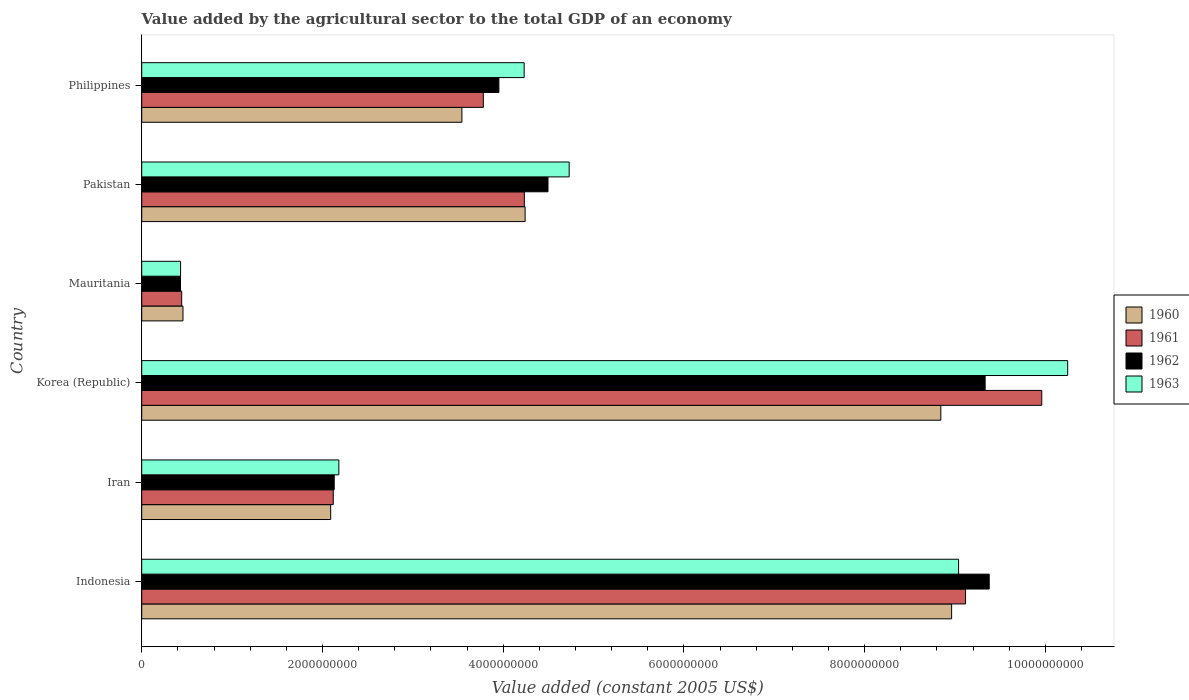How many groups of bars are there?
Give a very brief answer. 6. Are the number of bars per tick equal to the number of legend labels?
Your answer should be very brief. Yes. Are the number of bars on each tick of the Y-axis equal?
Your response must be concise. Yes. How many bars are there on the 2nd tick from the top?
Your answer should be very brief. 4. What is the value added by the agricultural sector in 1961 in Korea (Republic)?
Give a very brief answer. 9.96e+09. Across all countries, what is the maximum value added by the agricultural sector in 1960?
Your response must be concise. 8.96e+09. Across all countries, what is the minimum value added by the agricultural sector in 1961?
Provide a short and direct response. 4.42e+08. In which country was the value added by the agricultural sector in 1962 minimum?
Ensure brevity in your answer.  Mauritania. What is the total value added by the agricultural sector in 1961 in the graph?
Offer a very short reply. 2.97e+1. What is the difference between the value added by the agricultural sector in 1961 in Pakistan and that in Philippines?
Your answer should be very brief. 4.54e+08. What is the difference between the value added by the agricultural sector in 1963 in Indonesia and the value added by the agricultural sector in 1961 in Philippines?
Offer a terse response. 5.26e+09. What is the average value added by the agricultural sector in 1960 per country?
Provide a short and direct response. 4.69e+09. What is the difference between the value added by the agricultural sector in 1962 and value added by the agricultural sector in 1963 in Mauritania?
Keep it short and to the point. -7.06e+05. What is the ratio of the value added by the agricultural sector in 1960 in Indonesia to that in Korea (Republic)?
Offer a very short reply. 1.01. What is the difference between the highest and the second highest value added by the agricultural sector in 1963?
Your answer should be very brief. 1.21e+09. What is the difference between the highest and the lowest value added by the agricultural sector in 1960?
Ensure brevity in your answer.  8.51e+09. In how many countries, is the value added by the agricultural sector in 1963 greater than the average value added by the agricultural sector in 1963 taken over all countries?
Give a very brief answer. 2. What does the 4th bar from the top in Mauritania represents?
Your answer should be very brief. 1960. What does the 1st bar from the bottom in Mauritania represents?
Provide a succinct answer. 1960. Are all the bars in the graph horizontal?
Provide a short and direct response. Yes. How many countries are there in the graph?
Your response must be concise. 6. Does the graph contain any zero values?
Keep it short and to the point. No. Does the graph contain grids?
Give a very brief answer. No. How many legend labels are there?
Offer a terse response. 4. How are the legend labels stacked?
Offer a terse response. Vertical. What is the title of the graph?
Your response must be concise. Value added by the agricultural sector to the total GDP of an economy. Does "1961" appear as one of the legend labels in the graph?
Your answer should be very brief. Yes. What is the label or title of the X-axis?
Make the answer very short. Value added (constant 2005 US$). What is the label or title of the Y-axis?
Make the answer very short. Country. What is the Value added (constant 2005 US$) in 1960 in Indonesia?
Keep it short and to the point. 8.96e+09. What is the Value added (constant 2005 US$) in 1961 in Indonesia?
Provide a short and direct response. 9.12e+09. What is the Value added (constant 2005 US$) in 1962 in Indonesia?
Your response must be concise. 9.38e+09. What is the Value added (constant 2005 US$) in 1963 in Indonesia?
Ensure brevity in your answer.  9.04e+09. What is the Value added (constant 2005 US$) in 1960 in Iran?
Ensure brevity in your answer.  2.09e+09. What is the Value added (constant 2005 US$) of 1961 in Iran?
Your response must be concise. 2.12e+09. What is the Value added (constant 2005 US$) in 1962 in Iran?
Offer a very short reply. 2.13e+09. What is the Value added (constant 2005 US$) in 1963 in Iran?
Ensure brevity in your answer.  2.18e+09. What is the Value added (constant 2005 US$) of 1960 in Korea (Republic)?
Your answer should be very brief. 8.84e+09. What is the Value added (constant 2005 US$) of 1961 in Korea (Republic)?
Your answer should be very brief. 9.96e+09. What is the Value added (constant 2005 US$) in 1962 in Korea (Republic)?
Make the answer very short. 9.33e+09. What is the Value added (constant 2005 US$) of 1963 in Korea (Republic)?
Your answer should be very brief. 1.02e+1. What is the Value added (constant 2005 US$) of 1960 in Mauritania?
Keep it short and to the point. 4.57e+08. What is the Value added (constant 2005 US$) in 1961 in Mauritania?
Ensure brevity in your answer.  4.42e+08. What is the Value added (constant 2005 US$) in 1962 in Mauritania?
Give a very brief answer. 4.29e+08. What is the Value added (constant 2005 US$) in 1963 in Mauritania?
Keep it short and to the point. 4.30e+08. What is the Value added (constant 2005 US$) in 1960 in Pakistan?
Make the answer very short. 4.24e+09. What is the Value added (constant 2005 US$) in 1961 in Pakistan?
Provide a short and direct response. 4.23e+09. What is the Value added (constant 2005 US$) of 1962 in Pakistan?
Keep it short and to the point. 4.50e+09. What is the Value added (constant 2005 US$) in 1963 in Pakistan?
Offer a terse response. 4.73e+09. What is the Value added (constant 2005 US$) of 1960 in Philippines?
Your response must be concise. 3.54e+09. What is the Value added (constant 2005 US$) in 1961 in Philippines?
Keep it short and to the point. 3.78e+09. What is the Value added (constant 2005 US$) in 1962 in Philippines?
Provide a succinct answer. 3.95e+09. What is the Value added (constant 2005 US$) of 1963 in Philippines?
Your response must be concise. 4.23e+09. Across all countries, what is the maximum Value added (constant 2005 US$) of 1960?
Ensure brevity in your answer.  8.96e+09. Across all countries, what is the maximum Value added (constant 2005 US$) in 1961?
Your response must be concise. 9.96e+09. Across all countries, what is the maximum Value added (constant 2005 US$) of 1962?
Your answer should be very brief. 9.38e+09. Across all countries, what is the maximum Value added (constant 2005 US$) of 1963?
Your response must be concise. 1.02e+1. Across all countries, what is the minimum Value added (constant 2005 US$) in 1960?
Give a very brief answer. 4.57e+08. Across all countries, what is the minimum Value added (constant 2005 US$) of 1961?
Offer a very short reply. 4.42e+08. Across all countries, what is the minimum Value added (constant 2005 US$) of 1962?
Ensure brevity in your answer.  4.29e+08. Across all countries, what is the minimum Value added (constant 2005 US$) of 1963?
Ensure brevity in your answer.  4.30e+08. What is the total Value added (constant 2005 US$) in 1960 in the graph?
Make the answer very short. 2.81e+1. What is the total Value added (constant 2005 US$) of 1961 in the graph?
Keep it short and to the point. 2.97e+1. What is the total Value added (constant 2005 US$) of 1962 in the graph?
Your response must be concise. 2.97e+1. What is the total Value added (constant 2005 US$) in 1963 in the graph?
Provide a short and direct response. 3.09e+1. What is the difference between the Value added (constant 2005 US$) in 1960 in Indonesia and that in Iran?
Make the answer very short. 6.87e+09. What is the difference between the Value added (constant 2005 US$) of 1961 in Indonesia and that in Iran?
Your answer should be compact. 7.00e+09. What is the difference between the Value added (constant 2005 US$) in 1962 in Indonesia and that in Iran?
Ensure brevity in your answer.  7.25e+09. What is the difference between the Value added (constant 2005 US$) in 1963 in Indonesia and that in Iran?
Make the answer very short. 6.86e+09. What is the difference between the Value added (constant 2005 US$) of 1960 in Indonesia and that in Korea (Republic)?
Your response must be concise. 1.19e+08. What is the difference between the Value added (constant 2005 US$) of 1961 in Indonesia and that in Korea (Republic)?
Offer a terse response. -8.44e+08. What is the difference between the Value added (constant 2005 US$) in 1962 in Indonesia and that in Korea (Republic)?
Your answer should be compact. 4.52e+07. What is the difference between the Value added (constant 2005 US$) in 1963 in Indonesia and that in Korea (Republic)?
Your response must be concise. -1.21e+09. What is the difference between the Value added (constant 2005 US$) of 1960 in Indonesia and that in Mauritania?
Your response must be concise. 8.51e+09. What is the difference between the Value added (constant 2005 US$) of 1961 in Indonesia and that in Mauritania?
Provide a succinct answer. 8.68e+09. What is the difference between the Value added (constant 2005 US$) in 1962 in Indonesia and that in Mauritania?
Keep it short and to the point. 8.95e+09. What is the difference between the Value added (constant 2005 US$) in 1963 in Indonesia and that in Mauritania?
Provide a succinct answer. 8.61e+09. What is the difference between the Value added (constant 2005 US$) in 1960 in Indonesia and that in Pakistan?
Your answer should be compact. 4.72e+09. What is the difference between the Value added (constant 2005 US$) of 1961 in Indonesia and that in Pakistan?
Your response must be concise. 4.88e+09. What is the difference between the Value added (constant 2005 US$) in 1962 in Indonesia and that in Pakistan?
Provide a succinct answer. 4.88e+09. What is the difference between the Value added (constant 2005 US$) of 1963 in Indonesia and that in Pakistan?
Offer a terse response. 4.31e+09. What is the difference between the Value added (constant 2005 US$) of 1960 in Indonesia and that in Philippines?
Make the answer very short. 5.42e+09. What is the difference between the Value added (constant 2005 US$) of 1961 in Indonesia and that in Philippines?
Your response must be concise. 5.34e+09. What is the difference between the Value added (constant 2005 US$) in 1962 in Indonesia and that in Philippines?
Keep it short and to the point. 5.43e+09. What is the difference between the Value added (constant 2005 US$) of 1963 in Indonesia and that in Philippines?
Offer a very short reply. 4.81e+09. What is the difference between the Value added (constant 2005 US$) of 1960 in Iran and that in Korea (Republic)?
Make the answer very short. -6.75e+09. What is the difference between the Value added (constant 2005 US$) in 1961 in Iran and that in Korea (Republic)?
Provide a short and direct response. -7.84e+09. What is the difference between the Value added (constant 2005 US$) of 1962 in Iran and that in Korea (Republic)?
Keep it short and to the point. -7.20e+09. What is the difference between the Value added (constant 2005 US$) of 1963 in Iran and that in Korea (Republic)?
Ensure brevity in your answer.  -8.07e+09. What is the difference between the Value added (constant 2005 US$) of 1960 in Iran and that in Mauritania?
Offer a terse response. 1.63e+09. What is the difference between the Value added (constant 2005 US$) of 1961 in Iran and that in Mauritania?
Offer a very short reply. 1.68e+09. What is the difference between the Value added (constant 2005 US$) in 1962 in Iran and that in Mauritania?
Your answer should be very brief. 1.70e+09. What is the difference between the Value added (constant 2005 US$) of 1963 in Iran and that in Mauritania?
Offer a very short reply. 1.75e+09. What is the difference between the Value added (constant 2005 US$) in 1960 in Iran and that in Pakistan?
Provide a short and direct response. -2.15e+09. What is the difference between the Value added (constant 2005 US$) in 1961 in Iran and that in Pakistan?
Make the answer very short. -2.11e+09. What is the difference between the Value added (constant 2005 US$) of 1962 in Iran and that in Pakistan?
Offer a terse response. -2.37e+09. What is the difference between the Value added (constant 2005 US$) of 1963 in Iran and that in Pakistan?
Offer a very short reply. -2.55e+09. What is the difference between the Value added (constant 2005 US$) of 1960 in Iran and that in Philippines?
Make the answer very short. -1.45e+09. What is the difference between the Value added (constant 2005 US$) of 1961 in Iran and that in Philippines?
Give a very brief answer. -1.66e+09. What is the difference between the Value added (constant 2005 US$) of 1962 in Iran and that in Philippines?
Provide a short and direct response. -1.82e+09. What is the difference between the Value added (constant 2005 US$) in 1963 in Iran and that in Philippines?
Offer a terse response. -2.05e+09. What is the difference between the Value added (constant 2005 US$) of 1960 in Korea (Republic) and that in Mauritania?
Offer a terse response. 8.39e+09. What is the difference between the Value added (constant 2005 US$) of 1961 in Korea (Republic) and that in Mauritania?
Your answer should be very brief. 9.52e+09. What is the difference between the Value added (constant 2005 US$) of 1962 in Korea (Republic) and that in Mauritania?
Your answer should be compact. 8.91e+09. What is the difference between the Value added (constant 2005 US$) in 1963 in Korea (Republic) and that in Mauritania?
Your answer should be very brief. 9.82e+09. What is the difference between the Value added (constant 2005 US$) in 1960 in Korea (Republic) and that in Pakistan?
Your answer should be very brief. 4.60e+09. What is the difference between the Value added (constant 2005 US$) in 1961 in Korea (Republic) and that in Pakistan?
Provide a short and direct response. 5.73e+09. What is the difference between the Value added (constant 2005 US$) of 1962 in Korea (Republic) and that in Pakistan?
Give a very brief answer. 4.84e+09. What is the difference between the Value added (constant 2005 US$) in 1963 in Korea (Republic) and that in Pakistan?
Provide a short and direct response. 5.52e+09. What is the difference between the Value added (constant 2005 US$) of 1960 in Korea (Republic) and that in Philippines?
Give a very brief answer. 5.30e+09. What is the difference between the Value added (constant 2005 US$) in 1961 in Korea (Republic) and that in Philippines?
Provide a short and direct response. 6.18e+09. What is the difference between the Value added (constant 2005 US$) of 1962 in Korea (Republic) and that in Philippines?
Ensure brevity in your answer.  5.38e+09. What is the difference between the Value added (constant 2005 US$) of 1963 in Korea (Republic) and that in Philippines?
Make the answer very short. 6.02e+09. What is the difference between the Value added (constant 2005 US$) in 1960 in Mauritania and that in Pakistan?
Give a very brief answer. -3.79e+09. What is the difference between the Value added (constant 2005 US$) in 1961 in Mauritania and that in Pakistan?
Provide a succinct answer. -3.79e+09. What is the difference between the Value added (constant 2005 US$) of 1962 in Mauritania and that in Pakistan?
Your answer should be very brief. -4.07e+09. What is the difference between the Value added (constant 2005 US$) of 1963 in Mauritania and that in Pakistan?
Keep it short and to the point. -4.30e+09. What is the difference between the Value added (constant 2005 US$) of 1960 in Mauritania and that in Philippines?
Provide a short and direct response. -3.09e+09. What is the difference between the Value added (constant 2005 US$) in 1961 in Mauritania and that in Philippines?
Your response must be concise. -3.34e+09. What is the difference between the Value added (constant 2005 US$) of 1962 in Mauritania and that in Philippines?
Offer a very short reply. -3.52e+09. What is the difference between the Value added (constant 2005 US$) of 1963 in Mauritania and that in Philippines?
Provide a succinct answer. -3.80e+09. What is the difference between the Value added (constant 2005 US$) in 1960 in Pakistan and that in Philippines?
Your answer should be compact. 7.00e+08. What is the difference between the Value added (constant 2005 US$) in 1961 in Pakistan and that in Philippines?
Offer a very short reply. 4.54e+08. What is the difference between the Value added (constant 2005 US$) of 1962 in Pakistan and that in Philippines?
Offer a very short reply. 5.44e+08. What is the difference between the Value added (constant 2005 US$) of 1963 in Pakistan and that in Philippines?
Your answer should be compact. 4.98e+08. What is the difference between the Value added (constant 2005 US$) in 1960 in Indonesia and the Value added (constant 2005 US$) in 1961 in Iran?
Your answer should be very brief. 6.84e+09. What is the difference between the Value added (constant 2005 US$) in 1960 in Indonesia and the Value added (constant 2005 US$) in 1962 in Iran?
Provide a short and direct response. 6.83e+09. What is the difference between the Value added (constant 2005 US$) in 1960 in Indonesia and the Value added (constant 2005 US$) in 1963 in Iran?
Offer a terse response. 6.78e+09. What is the difference between the Value added (constant 2005 US$) in 1961 in Indonesia and the Value added (constant 2005 US$) in 1962 in Iran?
Your response must be concise. 6.99e+09. What is the difference between the Value added (constant 2005 US$) of 1961 in Indonesia and the Value added (constant 2005 US$) of 1963 in Iran?
Your response must be concise. 6.94e+09. What is the difference between the Value added (constant 2005 US$) in 1962 in Indonesia and the Value added (constant 2005 US$) in 1963 in Iran?
Ensure brevity in your answer.  7.20e+09. What is the difference between the Value added (constant 2005 US$) of 1960 in Indonesia and the Value added (constant 2005 US$) of 1961 in Korea (Republic)?
Make the answer very short. -9.98e+08. What is the difference between the Value added (constant 2005 US$) of 1960 in Indonesia and the Value added (constant 2005 US$) of 1962 in Korea (Republic)?
Offer a terse response. -3.71e+08. What is the difference between the Value added (constant 2005 US$) of 1960 in Indonesia and the Value added (constant 2005 US$) of 1963 in Korea (Republic)?
Make the answer very short. -1.28e+09. What is the difference between the Value added (constant 2005 US$) of 1961 in Indonesia and the Value added (constant 2005 US$) of 1962 in Korea (Republic)?
Provide a succinct answer. -2.17e+08. What is the difference between the Value added (constant 2005 US$) in 1961 in Indonesia and the Value added (constant 2005 US$) in 1963 in Korea (Republic)?
Give a very brief answer. -1.13e+09. What is the difference between the Value added (constant 2005 US$) in 1962 in Indonesia and the Value added (constant 2005 US$) in 1963 in Korea (Republic)?
Offer a terse response. -8.69e+08. What is the difference between the Value added (constant 2005 US$) of 1960 in Indonesia and the Value added (constant 2005 US$) of 1961 in Mauritania?
Your response must be concise. 8.52e+09. What is the difference between the Value added (constant 2005 US$) of 1960 in Indonesia and the Value added (constant 2005 US$) of 1962 in Mauritania?
Provide a succinct answer. 8.53e+09. What is the difference between the Value added (constant 2005 US$) in 1960 in Indonesia and the Value added (constant 2005 US$) in 1963 in Mauritania?
Make the answer very short. 8.53e+09. What is the difference between the Value added (constant 2005 US$) of 1961 in Indonesia and the Value added (constant 2005 US$) of 1962 in Mauritania?
Offer a terse response. 8.69e+09. What is the difference between the Value added (constant 2005 US$) in 1961 in Indonesia and the Value added (constant 2005 US$) in 1963 in Mauritania?
Provide a succinct answer. 8.69e+09. What is the difference between the Value added (constant 2005 US$) of 1962 in Indonesia and the Value added (constant 2005 US$) of 1963 in Mauritania?
Your answer should be very brief. 8.95e+09. What is the difference between the Value added (constant 2005 US$) of 1960 in Indonesia and the Value added (constant 2005 US$) of 1961 in Pakistan?
Your response must be concise. 4.73e+09. What is the difference between the Value added (constant 2005 US$) in 1960 in Indonesia and the Value added (constant 2005 US$) in 1962 in Pakistan?
Your answer should be compact. 4.47e+09. What is the difference between the Value added (constant 2005 US$) in 1960 in Indonesia and the Value added (constant 2005 US$) in 1963 in Pakistan?
Keep it short and to the point. 4.23e+09. What is the difference between the Value added (constant 2005 US$) of 1961 in Indonesia and the Value added (constant 2005 US$) of 1962 in Pakistan?
Make the answer very short. 4.62e+09. What is the difference between the Value added (constant 2005 US$) in 1961 in Indonesia and the Value added (constant 2005 US$) in 1963 in Pakistan?
Ensure brevity in your answer.  4.39e+09. What is the difference between the Value added (constant 2005 US$) in 1962 in Indonesia and the Value added (constant 2005 US$) in 1963 in Pakistan?
Your response must be concise. 4.65e+09. What is the difference between the Value added (constant 2005 US$) of 1960 in Indonesia and the Value added (constant 2005 US$) of 1961 in Philippines?
Your answer should be very brief. 5.18e+09. What is the difference between the Value added (constant 2005 US$) in 1960 in Indonesia and the Value added (constant 2005 US$) in 1962 in Philippines?
Offer a terse response. 5.01e+09. What is the difference between the Value added (constant 2005 US$) in 1960 in Indonesia and the Value added (constant 2005 US$) in 1963 in Philippines?
Make the answer very short. 4.73e+09. What is the difference between the Value added (constant 2005 US$) of 1961 in Indonesia and the Value added (constant 2005 US$) of 1962 in Philippines?
Keep it short and to the point. 5.16e+09. What is the difference between the Value added (constant 2005 US$) of 1961 in Indonesia and the Value added (constant 2005 US$) of 1963 in Philippines?
Ensure brevity in your answer.  4.88e+09. What is the difference between the Value added (constant 2005 US$) in 1962 in Indonesia and the Value added (constant 2005 US$) in 1963 in Philippines?
Your answer should be compact. 5.15e+09. What is the difference between the Value added (constant 2005 US$) in 1960 in Iran and the Value added (constant 2005 US$) in 1961 in Korea (Republic)?
Your answer should be compact. -7.87e+09. What is the difference between the Value added (constant 2005 US$) of 1960 in Iran and the Value added (constant 2005 US$) of 1962 in Korea (Republic)?
Offer a very short reply. -7.24e+09. What is the difference between the Value added (constant 2005 US$) of 1960 in Iran and the Value added (constant 2005 US$) of 1963 in Korea (Republic)?
Your answer should be very brief. -8.16e+09. What is the difference between the Value added (constant 2005 US$) in 1961 in Iran and the Value added (constant 2005 US$) in 1962 in Korea (Republic)?
Ensure brevity in your answer.  -7.21e+09. What is the difference between the Value added (constant 2005 US$) in 1961 in Iran and the Value added (constant 2005 US$) in 1963 in Korea (Republic)?
Your answer should be compact. -8.13e+09. What is the difference between the Value added (constant 2005 US$) in 1962 in Iran and the Value added (constant 2005 US$) in 1963 in Korea (Republic)?
Offer a terse response. -8.12e+09. What is the difference between the Value added (constant 2005 US$) of 1960 in Iran and the Value added (constant 2005 US$) of 1961 in Mauritania?
Provide a short and direct response. 1.65e+09. What is the difference between the Value added (constant 2005 US$) in 1960 in Iran and the Value added (constant 2005 US$) in 1962 in Mauritania?
Give a very brief answer. 1.66e+09. What is the difference between the Value added (constant 2005 US$) of 1960 in Iran and the Value added (constant 2005 US$) of 1963 in Mauritania?
Give a very brief answer. 1.66e+09. What is the difference between the Value added (constant 2005 US$) in 1961 in Iran and the Value added (constant 2005 US$) in 1962 in Mauritania?
Give a very brief answer. 1.69e+09. What is the difference between the Value added (constant 2005 US$) of 1961 in Iran and the Value added (constant 2005 US$) of 1963 in Mauritania?
Your response must be concise. 1.69e+09. What is the difference between the Value added (constant 2005 US$) of 1962 in Iran and the Value added (constant 2005 US$) of 1963 in Mauritania?
Your answer should be very brief. 1.70e+09. What is the difference between the Value added (constant 2005 US$) of 1960 in Iran and the Value added (constant 2005 US$) of 1961 in Pakistan?
Offer a very short reply. -2.14e+09. What is the difference between the Value added (constant 2005 US$) in 1960 in Iran and the Value added (constant 2005 US$) in 1962 in Pakistan?
Provide a short and direct response. -2.40e+09. What is the difference between the Value added (constant 2005 US$) of 1960 in Iran and the Value added (constant 2005 US$) of 1963 in Pakistan?
Ensure brevity in your answer.  -2.64e+09. What is the difference between the Value added (constant 2005 US$) of 1961 in Iran and the Value added (constant 2005 US$) of 1962 in Pakistan?
Give a very brief answer. -2.38e+09. What is the difference between the Value added (constant 2005 US$) of 1961 in Iran and the Value added (constant 2005 US$) of 1963 in Pakistan?
Your response must be concise. -2.61e+09. What is the difference between the Value added (constant 2005 US$) in 1962 in Iran and the Value added (constant 2005 US$) in 1963 in Pakistan?
Offer a very short reply. -2.60e+09. What is the difference between the Value added (constant 2005 US$) in 1960 in Iran and the Value added (constant 2005 US$) in 1961 in Philippines?
Offer a terse response. -1.69e+09. What is the difference between the Value added (constant 2005 US$) in 1960 in Iran and the Value added (constant 2005 US$) in 1962 in Philippines?
Ensure brevity in your answer.  -1.86e+09. What is the difference between the Value added (constant 2005 US$) of 1960 in Iran and the Value added (constant 2005 US$) of 1963 in Philippines?
Your answer should be compact. -2.14e+09. What is the difference between the Value added (constant 2005 US$) of 1961 in Iran and the Value added (constant 2005 US$) of 1962 in Philippines?
Provide a succinct answer. -1.83e+09. What is the difference between the Value added (constant 2005 US$) of 1961 in Iran and the Value added (constant 2005 US$) of 1963 in Philippines?
Ensure brevity in your answer.  -2.11e+09. What is the difference between the Value added (constant 2005 US$) in 1962 in Iran and the Value added (constant 2005 US$) in 1963 in Philippines?
Give a very brief answer. -2.10e+09. What is the difference between the Value added (constant 2005 US$) of 1960 in Korea (Republic) and the Value added (constant 2005 US$) of 1961 in Mauritania?
Your answer should be compact. 8.40e+09. What is the difference between the Value added (constant 2005 US$) of 1960 in Korea (Republic) and the Value added (constant 2005 US$) of 1962 in Mauritania?
Make the answer very short. 8.41e+09. What is the difference between the Value added (constant 2005 US$) of 1960 in Korea (Republic) and the Value added (constant 2005 US$) of 1963 in Mauritania?
Your response must be concise. 8.41e+09. What is the difference between the Value added (constant 2005 US$) in 1961 in Korea (Republic) and the Value added (constant 2005 US$) in 1962 in Mauritania?
Keep it short and to the point. 9.53e+09. What is the difference between the Value added (constant 2005 US$) of 1961 in Korea (Republic) and the Value added (constant 2005 US$) of 1963 in Mauritania?
Provide a short and direct response. 9.53e+09. What is the difference between the Value added (constant 2005 US$) in 1962 in Korea (Republic) and the Value added (constant 2005 US$) in 1963 in Mauritania?
Keep it short and to the point. 8.90e+09. What is the difference between the Value added (constant 2005 US$) of 1960 in Korea (Republic) and the Value added (constant 2005 US$) of 1961 in Pakistan?
Your answer should be very brief. 4.61e+09. What is the difference between the Value added (constant 2005 US$) in 1960 in Korea (Republic) and the Value added (constant 2005 US$) in 1962 in Pakistan?
Provide a succinct answer. 4.35e+09. What is the difference between the Value added (constant 2005 US$) of 1960 in Korea (Republic) and the Value added (constant 2005 US$) of 1963 in Pakistan?
Your answer should be compact. 4.11e+09. What is the difference between the Value added (constant 2005 US$) of 1961 in Korea (Republic) and the Value added (constant 2005 US$) of 1962 in Pakistan?
Offer a very short reply. 5.46e+09. What is the difference between the Value added (constant 2005 US$) in 1961 in Korea (Republic) and the Value added (constant 2005 US$) in 1963 in Pakistan?
Your response must be concise. 5.23e+09. What is the difference between the Value added (constant 2005 US$) of 1962 in Korea (Republic) and the Value added (constant 2005 US$) of 1963 in Pakistan?
Provide a short and direct response. 4.60e+09. What is the difference between the Value added (constant 2005 US$) in 1960 in Korea (Republic) and the Value added (constant 2005 US$) in 1961 in Philippines?
Give a very brief answer. 5.06e+09. What is the difference between the Value added (constant 2005 US$) of 1960 in Korea (Republic) and the Value added (constant 2005 US$) of 1962 in Philippines?
Keep it short and to the point. 4.89e+09. What is the difference between the Value added (constant 2005 US$) in 1960 in Korea (Republic) and the Value added (constant 2005 US$) in 1963 in Philippines?
Provide a short and direct response. 4.61e+09. What is the difference between the Value added (constant 2005 US$) of 1961 in Korea (Republic) and the Value added (constant 2005 US$) of 1962 in Philippines?
Ensure brevity in your answer.  6.01e+09. What is the difference between the Value added (constant 2005 US$) in 1961 in Korea (Republic) and the Value added (constant 2005 US$) in 1963 in Philippines?
Give a very brief answer. 5.73e+09. What is the difference between the Value added (constant 2005 US$) in 1962 in Korea (Republic) and the Value added (constant 2005 US$) in 1963 in Philippines?
Keep it short and to the point. 5.10e+09. What is the difference between the Value added (constant 2005 US$) of 1960 in Mauritania and the Value added (constant 2005 US$) of 1961 in Pakistan?
Provide a short and direct response. -3.78e+09. What is the difference between the Value added (constant 2005 US$) in 1960 in Mauritania and the Value added (constant 2005 US$) in 1962 in Pakistan?
Give a very brief answer. -4.04e+09. What is the difference between the Value added (constant 2005 US$) in 1960 in Mauritania and the Value added (constant 2005 US$) in 1963 in Pakistan?
Your response must be concise. -4.27e+09. What is the difference between the Value added (constant 2005 US$) of 1961 in Mauritania and the Value added (constant 2005 US$) of 1962 in Pakistan?
Provide a succinct answer. -4.05e+09. What is the difference between the Value added (constant 2005 US$) in 1961 in Mauritania and the Value added (constant 2005 US$) in 1963 in Pakistan?
Give a very brief answer. -4.29e+09. What is the difference between the Value added (constant 2005 US$) of 1962 in Mauritania and the Value added (constant 2005 US$) of 1963 in Pakistan?
Your answer should be very brief. -4.30e+09. What is the difference between the Value added (constant 2005 US$) in 1960 in Mauritania and the Value added (constant 2005 US$) in 1961 in Philippines?
Your answer should be very brief. -3.32e+09. What is the difference between the Value added (constant 2005 US$) of 1960 in Mauritania and the Value added (constant 2005 US$) of 1962 in Philippines?
Make the answer very short. -3.50e+09. What is the difference between the Value added (constant 2005 US$) in 1960 in Mauritania and the Value added (constant 2005 US$) in 1963 in Philippines?
Your answer should be very brief. -3.78e+09. What is the difference between the Value added (constant 2005 US$) of 1961 in Mauritania and the Value added (constant 2005 US$) of 1962 in Philippines?
Your response must be concise. -3.51e+09. What is the difference between the Value added (constant 2005 US$) of 1961 in Mauritania and the Value added (constant 2005 US$) of 1963 in Philippines?
Keep it short and to the point. -3.79e+09. What is the difference between the Value added (constant 2005 US$) of 1962 in Mauritania and the Value added (constant 2005 US$) of 1963 in Philippines?
Ensure brevity in your answer.  -3.80e+09. What is the difference between the Value added (constant 2005 US$) in 1960 in Pakistan and the Value added (constant 2005 US$) in 1961 in Philippines?
Make the answer very short. 4.62e+08. What is the difference between the Value added (constant 2005 US$) in 1960 in Pakistan and the Value added (constant 2005 US$) in 1962 in Philippines?
Give a very brief answer. 2.90e+08. What is the difference between the Value added (constant 2005 US$) of 1960 in Pakistan and the Value added (constant 2005 US$) of 1963 in Philippines?
Offer a terse response. 1.07e+07. What is the difference between the Value added (constant 2005 US$) of 1961 in Pakistan and the Value added (constant 2005 US$) of 1962 in Philippines?
Provide a succinct answer. 2.82e+08. What is the difference between the Value added (constant 2005 US$) in 1961 in Pakistan and the Value added (constant 2005 US$) in 1963 in Philippines?
Offer a terse response. 2.10e+06. What is the difference between the Value added (constant 2005 US$) in 1962 in Pakistan and the Value added (constant 2005 US$) in 1963 in Philippines?
Give a very brief answer. 2.64e+08. What is the average Value added (constant 2005 US$) in 1960 per country?
Ensure brevity in your answer.  4.69e+09. What is the average Value added (constant 2005 US$) of 1961 per country?
Keep it short and to the point. 4.94e+09. What is the average Value added (constant 2005 US$) of 1962 per country?
Make the answer very short. 4.95e+09. What is the average Value added (constant 2005 US$) in 1963 per country?
Offer a terse response. 5.14e+09. What is the difference between the Value added (constant 2005 US$) in 1960 and Value added (constant 2005 US$) in 1961 in Indonesia?
Ensure brevity in your answer.  -1.54e+08. What is the difference between the Value added (constant 2005 US$) of 1960 and Value added (constant 2005 US$) of 1962 in Indonesia?
Provide a succinct answer. -4.16e+08. What is the difference between the Value added (constant 2005 US$) in 1960 and Value added (constant 2005 US$) in 1963 in Indonesia?
Ensure brevity in your answer.  -7.71e+07. What is the difference between the Value added (constant 2005 US$) in 1961 and Value added (constant 2005 US$) in 1962 in Indonesia?
Your answer should be very brief. -2.62e+08. What is the difference between the Value added (constant 2005 US$) in 1961 and Value added (constant 2005 US$) in 1963 in Indonesia?
Your answer should be compact. 7.71e+07. What is the difference between the Value added (constant 2005 US$) in 1962 and Value added (constant 2005 US$) in 1963 in Indonesia?
Offer a terse response. 3.39e+08. What is the difference between the Value added (constant 2005 US$) of 1960 and Value added (constant 2005 US$) of 1961 in Iran?
Ensure brevity in your answer.  -2.84e+07. What is the difference between the Value added (constant 2005 US$) of 1960 and Value added (constant 2005 US$) of 1962 in Iran?
Your answer should be very brief. -3.89e+07. What is the difference between the Value added (constant 2005 US$) of 1960 and Value added (constant 2005 US$) of 1963 in Iran?
Your answer should be very brief. -9.02e+07. What is the difference between the Value added (constant 2005 US$) in 1961 and Value added (constant 2005 US$) in 1962 in Iran?
Offer a very short reply. -1.05e+07. What is the difference between the Value added (constant 2005 US$) in 1961 and Value added (constant 2005 US$) in 1963 in Iran?
Give a very brief answer. -6.18e+07. What is the difference between the Value added (constant 2005 US$) of 1962 and Value added (constant 2005 US$) of 1963 in Iran?
Offer a very short reply. -5.13e+07. What is the difference between the Value added (constant 2005 US$) of 1960 and Value added (constant 2005 US$) of 1961 in Korea (Republic)?
Your answer should be very brief. -1.12e+09. What is the difference between the Value added (constant 2005 US$) in 1960 and Value added (constant 2005 US$) in 1962 in Korea (Republic)?
Provide a succinct answer. -4.90e+08. What is the difference between the Value added (constant 2005 US$) in 1960 and Value added (constant 2005 US$) in 1963 in Korea (Republic)?
Provide a succinct answer. -1.40e+09. What is the difference between the Value added (constant 2005 US$) in 1961 and Value added (constant 2005 US$) in 1962 in Korea (Republic)?
Provide a short and direct response. 6.27e+08. What is the difference between the Value added (constant 2005 US$) in 1961 and Value added (constant 2005 US$) in 1963 in Korea (Republic)?
Provide a short and direct response. -2.87e+08. What is the difference between the Value added (constant 2005 US$) in 1962 and Value added (constant 2005 US$) in 1963 in Korea (Republic)?
Provide a short and direct response. -9.14e+08. What is the difference between the Value added (constant 2005 US$) in 1960 and Value added (constant 2005 US$) in 1961 in Mauritania?
Make the answer very short. 1.44e+07. What is the difference between the Value added (constant 2005 US$) of 1960 and Value added (constant 2005 US$) of 1962 in Mauritania?
Provide a short and direct response. 2.75e+07. What is the difference between the Value added (constant 2005 US$) of 1960 and Value added (constant 2005 US$) of 1963 in Mauritania?
Your answer should be compact. 2.68e+07. What is the difference between the Value added (constant 2005 US$) of 1961 and Value added (constant 2005 US$) of 1962 in Mauritania?
Keep it short and to the point. 1.31e+07. What is the difference between the Value added (constant 2005 US$) of 1961 and Value added (constant 2005 US$) of 1963 in Mauritania?
Offer a terse response. 1.24e+07. What is the difference between the Value added (constant 2005 US$) of 1962 and Value added (constant 2005 US$) of 1963 in Mauritania?
Ensure brevity in your answer.  -7.06e+05. What is the difference between the Value added (constant 2005 US$) of 1960 and Value added (constant 2005 US$) of 1961 in Pakistan?
Offer a terse response. 8.56e+06. What is the difference between the Value added (constant 2005 US$) of 1960 and Value added (constant 2005 US$) of 1962 in Pakistan?
Make the answer very short. -2.53e+08. What is the difference between the Value added (constant 2005 US$) in 1960 and Value added (constant 2005 US$) in 1963 in Pakistan?
Offer a very short reply. -4.87e+08. What is the difference between the Value added (constant 2005 US$) of 1961 and Value added (constant 2005 US$) of 1962 in Pakistan?
Offer a terse response. -2.62e+08. What is the difference between the Value added (constant 2005 US$) in 1961 and Value added (constant 2005 US$) in 1963 in Pakistan?
Provide a short and direct response. -4.96e+08. What is the difference between the Value added (constant 2005 US$) of 1962 and Value added (constant 2005 US$) of 1963 in Pakistan?
Your answer should be very brief. -2.34e+08. What is the difference between the Value added (constant 2005 US$) of 1960 and Value added (constant 2005 US$) of 1961 in Philippines?
Offer a terse response. -2.37e+08. What is the difference between the Value added (constant 2005 US$) in 1960 and Value added (constant 2005 US$) in 1962 in Philippines?
Provide a succinct answer. -4.09e+08. What is the difference between the Value added (constant 2005 US$) of 1960 and Value added (constant 2005 US$) of 1963 in Philippines?
Your response must be concise. -6.89e+08. What is the difference between the Value added (constant 2005 US$) of 1961 and Value added (constant 2005 US$) of 1962 in Philippines?
Provide a short and direct response. -1.72e+08. What is the difference between the Value added (constant 2005 US$) in 1961 and Value added (constant 2005 US$) in 1963 in Philippines?
Offer a terse response. -4.52e+08. What is the difference between the Value added (constant 2005 US$) of 1962 and Value added (constant 2005 US$) of 1963 in Philippines?
Offer a terse response. -2.80e+08. What is the ratio of the Value added (constant 2005 US$) of 1960 in Indonesia to that in Iran?
Ensure brevity in your answer.  4.29. What is the ratio of the Value added (constant 2005 US$) of 1961 in Indonesia to that in Iran?
Keep it short and to the point. 4.3. What is the ratio of the Value added (constant 2005 US$) of 1962 in Indonesia to that in Iran?
Give a very brief answer. 4.4. What is the ratio of the Value added (constant 2005 US$) in 1963 in Indonesia to that in Iran?
Make the answer very short. 4.14. What is the ratio of the Value added (constant 2005 US$) of 1960 in Indonesia to that in Korea (Republic)?
Your response must be concise. 1.01. What is the ratio of the Value added (constant 2005 US$) in 1961 in Indonesia to that in Korea (Republic)?
Keep it short and to the point. 0.92. What is the ratio of the Value added (constant 2005 US$) in 1963 in Indonesia to that in Korea (Republic)?
Your response must be concise. 0.88. What is the ratio of the Value added (constant 2005 US$) in 1960 in Indonesia to that in Mauritania?
Provide a short and direct response. 19.63. What is the ratio of the Value added (constant 2005 US$) of 1961 in Indonesia to that in Mauritania?
Offer a very short reply. 20.62. What is the ratio of the Value added (constant 2005 US$) of 1962 in Indonesia to that in Mauritania?
Your response must be concise. 21.86. What is the ratio of the Value added (constant 2005 US$) of 1963 in Indonesia to that in Mauritania?
Your answer should be very brief. 21.03. What is the ratio of the Value added (constant 2005 US$) in 1960 in Indonesia to that in Pakistan?
Your answer should be very brief. 2.11. What is the ratio of the Value added (constant 2005 US$) in 1961 in Indonesia to that in Pakistan?
Offer a very short reply. 2.15. What is the ratio of the Value added (constant 2005 US$) of 1962 in Indonesia to that in Pakistan?
Your answer should be very brief. 2.09. What is the ratio of the Value added (constant 2005 US$) of 1963 in Indonesia to that in Pakistan?
Your response must be concise. 1.91. What is the ratio of the Value added (constant 2005 US$) in 1960 in Indonesia to that in Philippines?
Your answer should be very brief. 2.53. What is the ratio of the Value added (constant 2005 US$) of 1961 in Indonesia to that in Philippines?
Your response must be concise. 2.41. What is the ratio of the Value added (constant 2005 US$) of 1962 in Indonesia to that in Philippines?
Provide a succinct answer. 2.37. What is the ratio of the Value added (constant 2005 US$) of 1963 in Indonesia to that in Philippines?
Offer a terse response. 2.14. What is the ratio of the Value added (constant 2005 US$) of 1960 in Iran to that in Korea (Republic)?
Make the answer very short. 0.24. What is the ratio of the Value added (constant 2005 US$) in 1961 in Iran to that in Korea (Republic)?
Your answer should be compact. 0.21. What is the ratio of the Value added (constant 2005 US$) of 1962 in Iran to that in Korea (Republic)?
Provide a succinct answer. 0.23. What is the ratio of the Value added (constant 2005 US$) of 1963 in Iran to that in Korea (Republic)?
Your response must be concise. 0.21. What is the ratio of the Value added (constant 2005 US$) in 1960 in Iran to that in Mauritania?
Keep it short and to the point. 4.58. What is the ratio of the Value added (constant 2005 US$) of 1961 in Iran to that in Mauritania?
Your answer should be compact. 4.79. What is the ratio of the Value added (constant 2005 US$) of 1962 in Iran to that in Mauritania?
Give a very brief answer. 4.96. What is the ratio of the Value added (constant 2005 US$) of 1963 in Iran to that in Mauritania?
Provide a succinct answer. 5.07. What is the ratio of the Value added (constant 2005 US$) in 1960 in Iran to that in Pakistan?
Provide a short and direct response. 0.49. What is the ratio of the Value added (constant 2005 US$) in 1961 in Iran to that in Pakistan?
Ensure brevity in your answer.  0.5. What is the ratio of the Value added (constant 2005 US$) in 1962 in Iran to that in Pakistan?
Your response must be concise. 0.47. What is the ratio of the Value added (constant 2005 US$) in 1963 in Iran to that in Pakistan?
Offer a terse response. 0.46. What is the ratio of the Value added (constant 2005 US$) of 1960 in Iran to that in Philippines?
Keep it short and to the point. 0.59. What is the ratio of the Value added (constant 2005 US$) in 1961 in Iran to that in Philippines?
Provide a short and direct response. 0.56. What is the ratio of the Value added (constant 2005 US$) of 1962 in Iran to that in Philippines?
Keep it short and to the point. 0.54. What is the ratio of the Value added (constant 2005 US$) of 1963 in Iran to that in Philippines?
Make the answer very short. 0.52. What is the ratio of the Value added (constant 2005 US$) in 1960 in Korea (Republic) to that in Mauritania?
Keep it short and to the point. 19.37. What is the ratio of the Value added (constant 2005 US$) of 1961 in Korea (Republic) to that in Mauritania?
Keep it short and to the point. 22.52. What is the ratio of the Value added (constant 2005 US$) of 1962 in Korea (Republic) to that in Mauritania?
Offer a terse response. 21.75. What is the ratio of the Value added (constant 2005 US$) in 1963 in Korea (Republic) to that in Mauritania?
Your answer should be compact. 23.84. What is the ratio of the Value added (constant 2005 US$) in 1960 in Korea (Republic) to that in Pakistan?
Offer a very short reply. 2.08. What is the ratio of the Value added (constant 2005 US$) in 1961 in Korea (Republic) to that in Pakistan?
Your answer should be compact. 2.35. What is the ratio of the Value added (constant 2005 US$) of 1962 in Korea (Republic) to that in Pakistan?
Your answer should be very brief. 2.08. What is the ratio of the Value added (constant 2005 US$) in 1963 in Korea (Republic) to that in Pakistan?
Keep it short and to the point. 2.17. What is the ratio of the Value added (constant 2005 US$) in 1960 in Korea (Republic) to that in Philippines?
Your response must be concise. 2.5. What is the ratio of the Value added (constant 2005 US$) in 1961 in Korea (Republic) to that in Philippines?
Your response must be concise. 2.63. What is the ratio of the Value added (constant 2005 US$) of 1962 in Korea (Republic) to that in Philippines?
Provide a succinct answer. 2.36. What is the ratio of the Value added (constant 2005 US$) of 1963 in Korea (Republic) to that in Philippines?
Keep it short and to the point. 2.42. What is the ratio of the Value added (constant 2005 US$) of 1960 in Mauritania to that in Pakistan?
Ensure brevity in your answer.  0.11. What is the ratio of the Value added (constant 2005 US$) in 1961 in Mauritania to that in Pakistan?
Your response must be concise. 0.1. What is the ratio of the Value added (constant 2005 US$) of 1962 in Mauritania to that in Pakistan?
Give a very brief answer. 0.1. What is the ratio of the Value added (constant 2005 US$) of 1963 in Mauritania to that in Pakistan?
Offer a very short reply. 0.09. What is the ratio of the Value added (constant 2005 US$) of 1960 in Mauritania to that in Philippines?
Your answer should be very brief. 0.13. What is the ratio of the Value added (constant 2005 US$) of 1961 in Mauritania to that in Philippines?
Give a very brief answer. 0.12. What is the ratio of the Value added (constant 2005 US$) in 1962 in Mauritania to that in Philippines?
Make the answer very short. 0.11. What is the ratio of the Value added (constant 2005 US$) in 1963 in Mauritania to that in Philippines?
Give a very brief answer. 0.1. What is the ratio of the Value added (constant 2005 US$) in 1960 in Pakistan to that in Philippines?
Give a very brief answer. 1.2. What is the ratio of the Value added (constant 2005 US$) of 1961 in Pakistan to that in Philippines?
Your answer should be very brief. 1.12. What is the ratio of the Value added (constant 2005 US$) in 1962 in Pakistan to that in Philippines?
Provide a short and direct response. 1.14. What is the ratio of the Value added (constant 2005 US$) in 1963 in Pakistan to that in Philippines?
Your answer should be compact. 1.12. What is the difference between the highest and the second highest Value added (constant 2005 US$) of 1960?
Your response must be concise. 1.19e+08. What is the difference between the highest and the second highest Value added (constant 2005 US$) of 1961?
Provide a short and direct response. 8.44e+08. What is the difference between the highest and the second highest Value added (constant 2005 US$) in 1962?
Provide a succinct answer. 4.52e+07. What is the difference between the highest and the second highest Value added (constant 2005 US$) of 1963?
Make the answer very short. 1.21e+09. What is the difference between the highest and the lowest Value added (constant 2005 US$) of 1960?
Your answer should be very brief. 8.51e+09. What is the difference between the highest and the lowest Value added (constant 2005 US$) of 1961?
Your answer should be compact. 9.52e+09. What is the difference between the highest and the lowest Value added (constant 2005 US$) in 1962?
Ensure brevity in your answer.  8.95e+09. What is the difference between the highest and the lowest Value added (constant 2005 US$) of 1963?
Ensure brevity in your answer.  9.82e+09. 